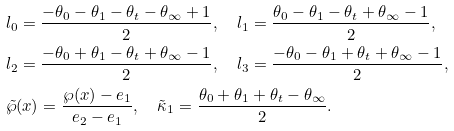Convert formula to latex. <formula><loc_0><loc_0><loc_500><loc_500>& l _ { 0 } = \frac { - \theta _ { 0 } - \theta _ { 1 } - \theta _ { t } - \theta _ { \infty } + 1 } { 2 } , \quad l _ { 1 } = \frac { \theta _ { 0 } - \theta _ { 1 } - \theta _ { t } + \theta _ { \infty } - 1 } { 2 } , \\ & l _ { 2 } = \frac { - \theta _ { 0 } + \theta _ { 1 } - \theta _ { t } + \theta _ { \infty } - 1 } { 2 } , \quad l _ { 3 } = \frac { - \theta _ { 0 } - \theta _ { 1 } + \theta _ { t } + \theta _ { \infty } - 1 } { 2 } , \\ & \tilde { \wp } ( x ) = \frac { \wp ( x ) - e _ { 1 } } { e _ { 2 } - e _ { 1 } } , \quad \tilde { \kappa } _ { 1 } = \frac { \theta _ { 0 } + \theta _ { 1 } + \theta _ { t } - \theta _ { \infty } } { 2 } .</formula> 